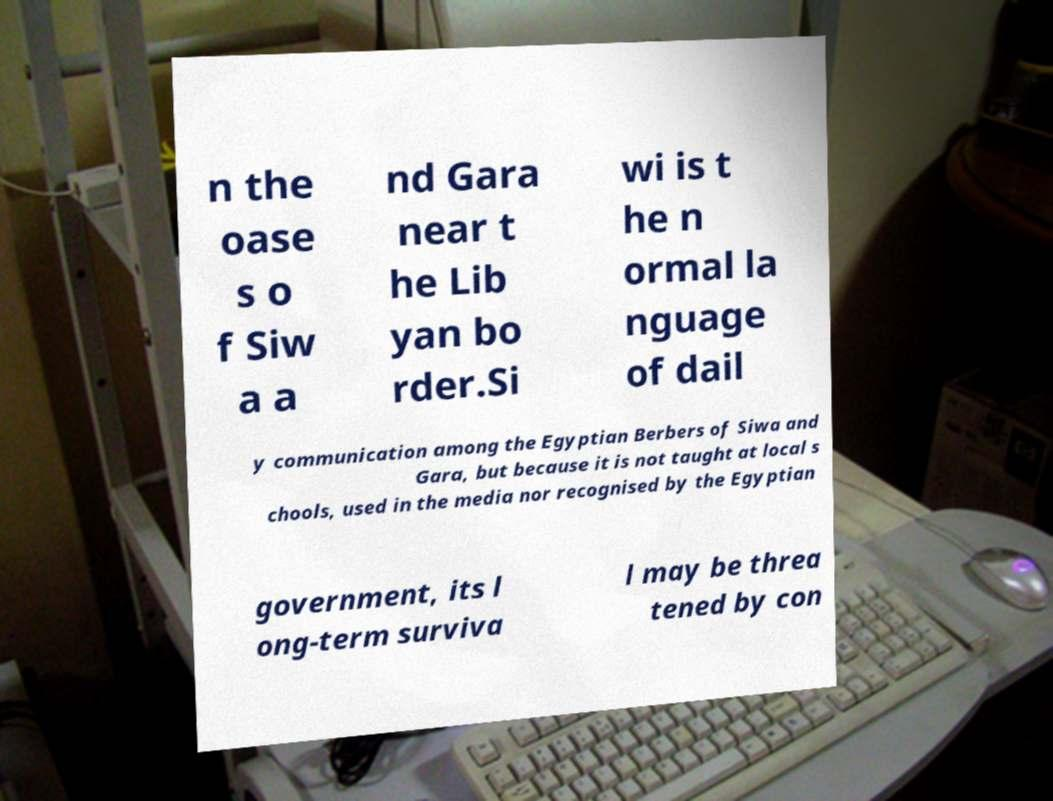Please read and relay the text visible in this image. What does it say? n the oase s o f Siw a a nd Gara near t he Lib yan bo rder.Si wi is t he n ormal la nguage of dail y communication among the Egyptian Berbers of Siwa and Gara, but because it is not taught at local s chools, used in the media nor recognised by the Egyptian government, its l ong-term surviva l may be threa tened by con 